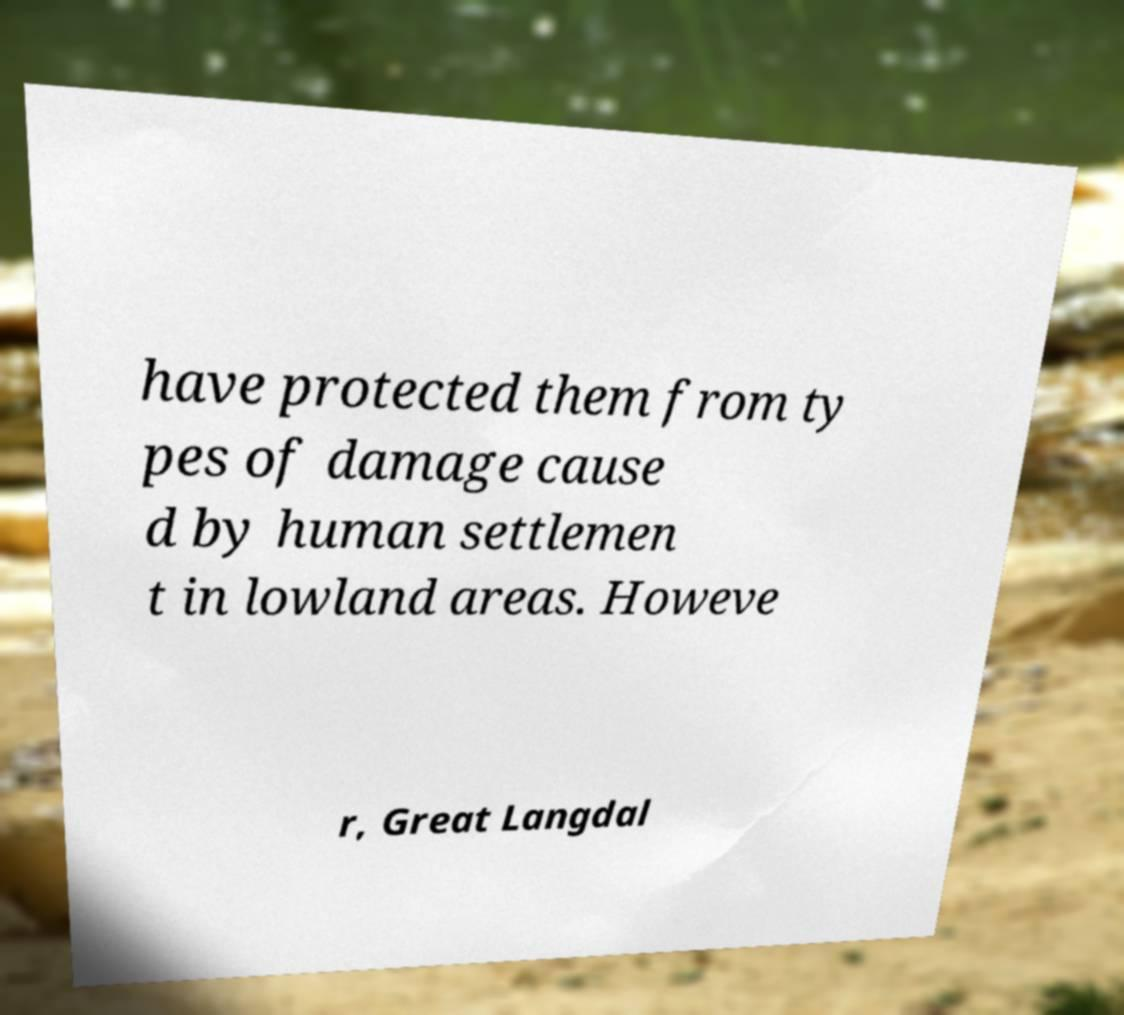For documentation purposes, I need the text within this image transcribed. Could you provide that? have protected them from ty pes of damage cause d by human settlemen t in lowland areas. Howeve r, Great Langdal 